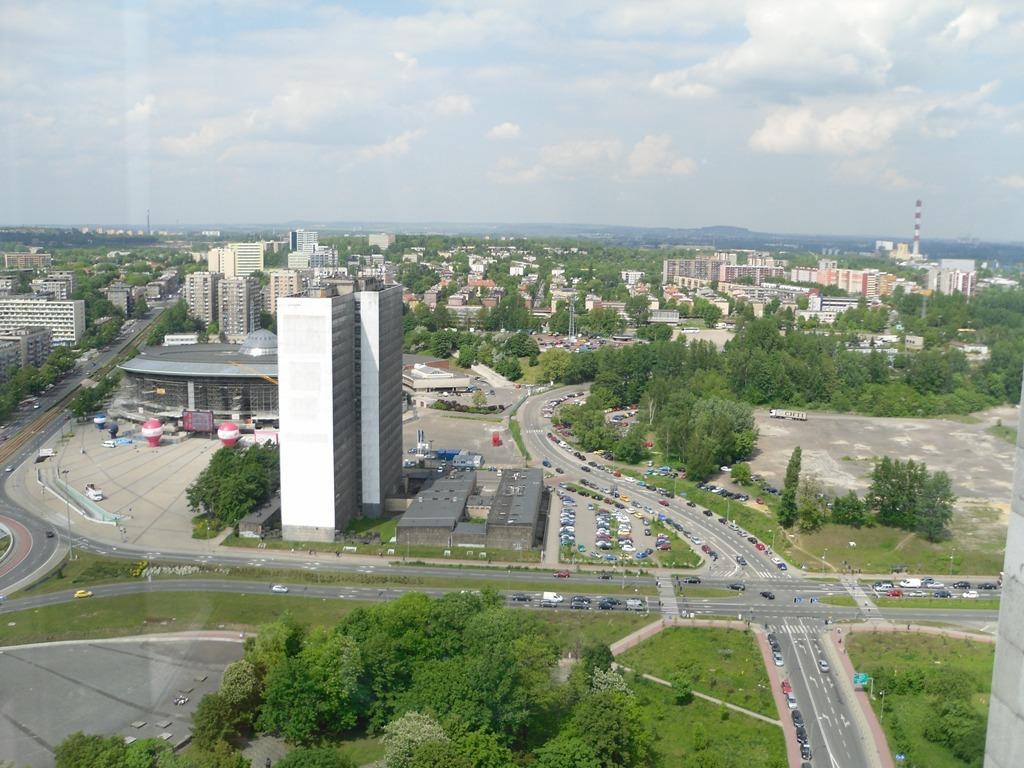Can you describe this image briefly? This is the picture of a city. In this image there are vehicles on the road. There are buildings and trees. On the right side of the image there is a tower. At the top there is sky and there are clouds. At the bottom there is a road and there is grass. 